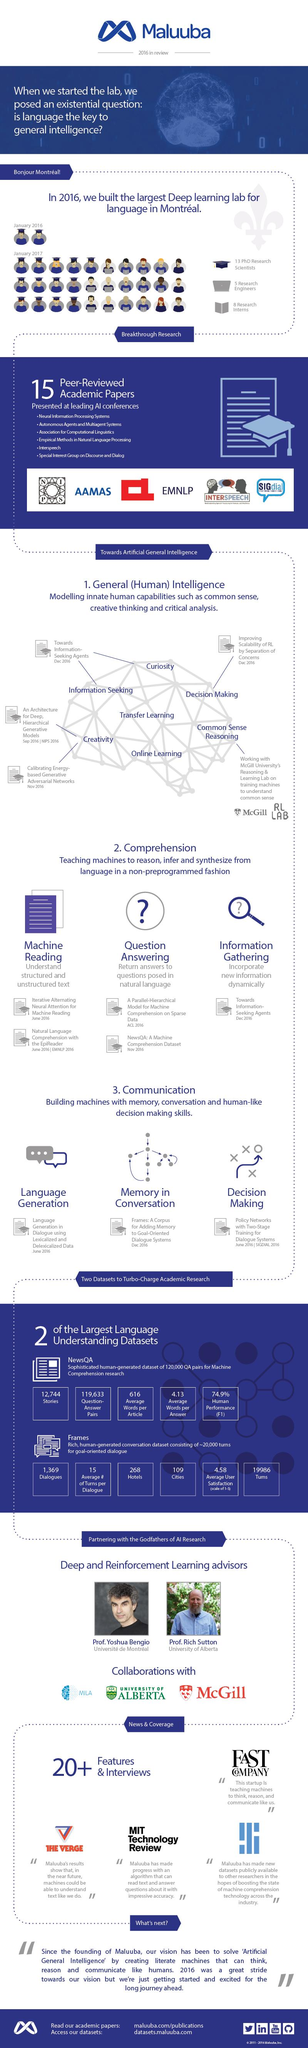Give some essential details in this illustration. There are approximately 12,744 stories. There are 1,369 dialogues. The average number of words per article is 616. There are 119,633 question-answer pairs. There are 109 cities in total. 